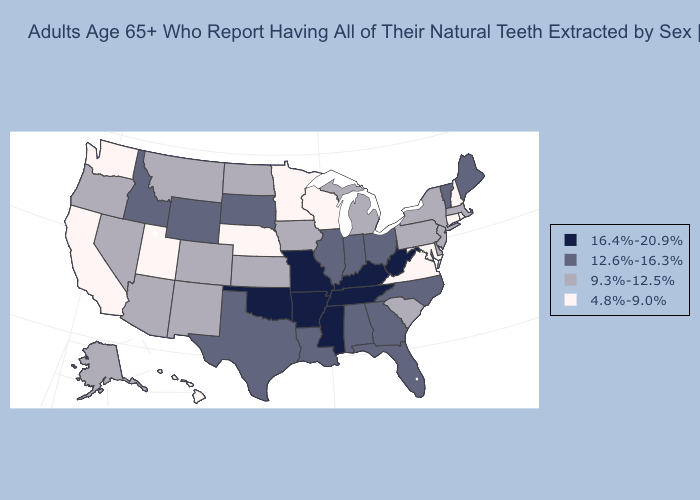Does Iowa have the lowest value in the USA?
Keep it brief. No. Does Oklahoma have the same value as Arkansas?
Write a very short answer. Yes. What is the lowest value in states that border New Hampshire?
Quick response, please. 9.3%-12.5%. What is the lowest value in the Northeast?
Write a very short answer. 4.8%-9.0%. Does Nebraska have the highest value in the USA?
Answer briefly. No. What is the value of Alabama?
Be succinct. 12.6%-16.3%. Name the states that have a value in the range 16.4%-20.9%?
Be succinct. Arkansas, Kentucky, Mississippi, Missouri, Oklahoma, Tennessee, West Virginia. Among the states that border Oklahoma , does New Mexico have the lowest value?
Answer briefly. Yes. What is the value of Pennsylvania?
Answer briefly. 9.3%-12.5%. Among the states that border Illinois , which have the lowest value?
Short answer required. Wisconsin. What is the value of New Mexico?
Concise answer only. 9.3%-12.5%. What is the value of South Dakota?
Answer briefly. 12.6%-16.3%. Does Oklahoma have the lowest value in the USA?
Answer briefly. No. Does Arkansas have the highest value in the USA?
Concise answer only. Yes. Does Wisconsin have the lowest value in the MidWest?
Be succinct. Yes. 